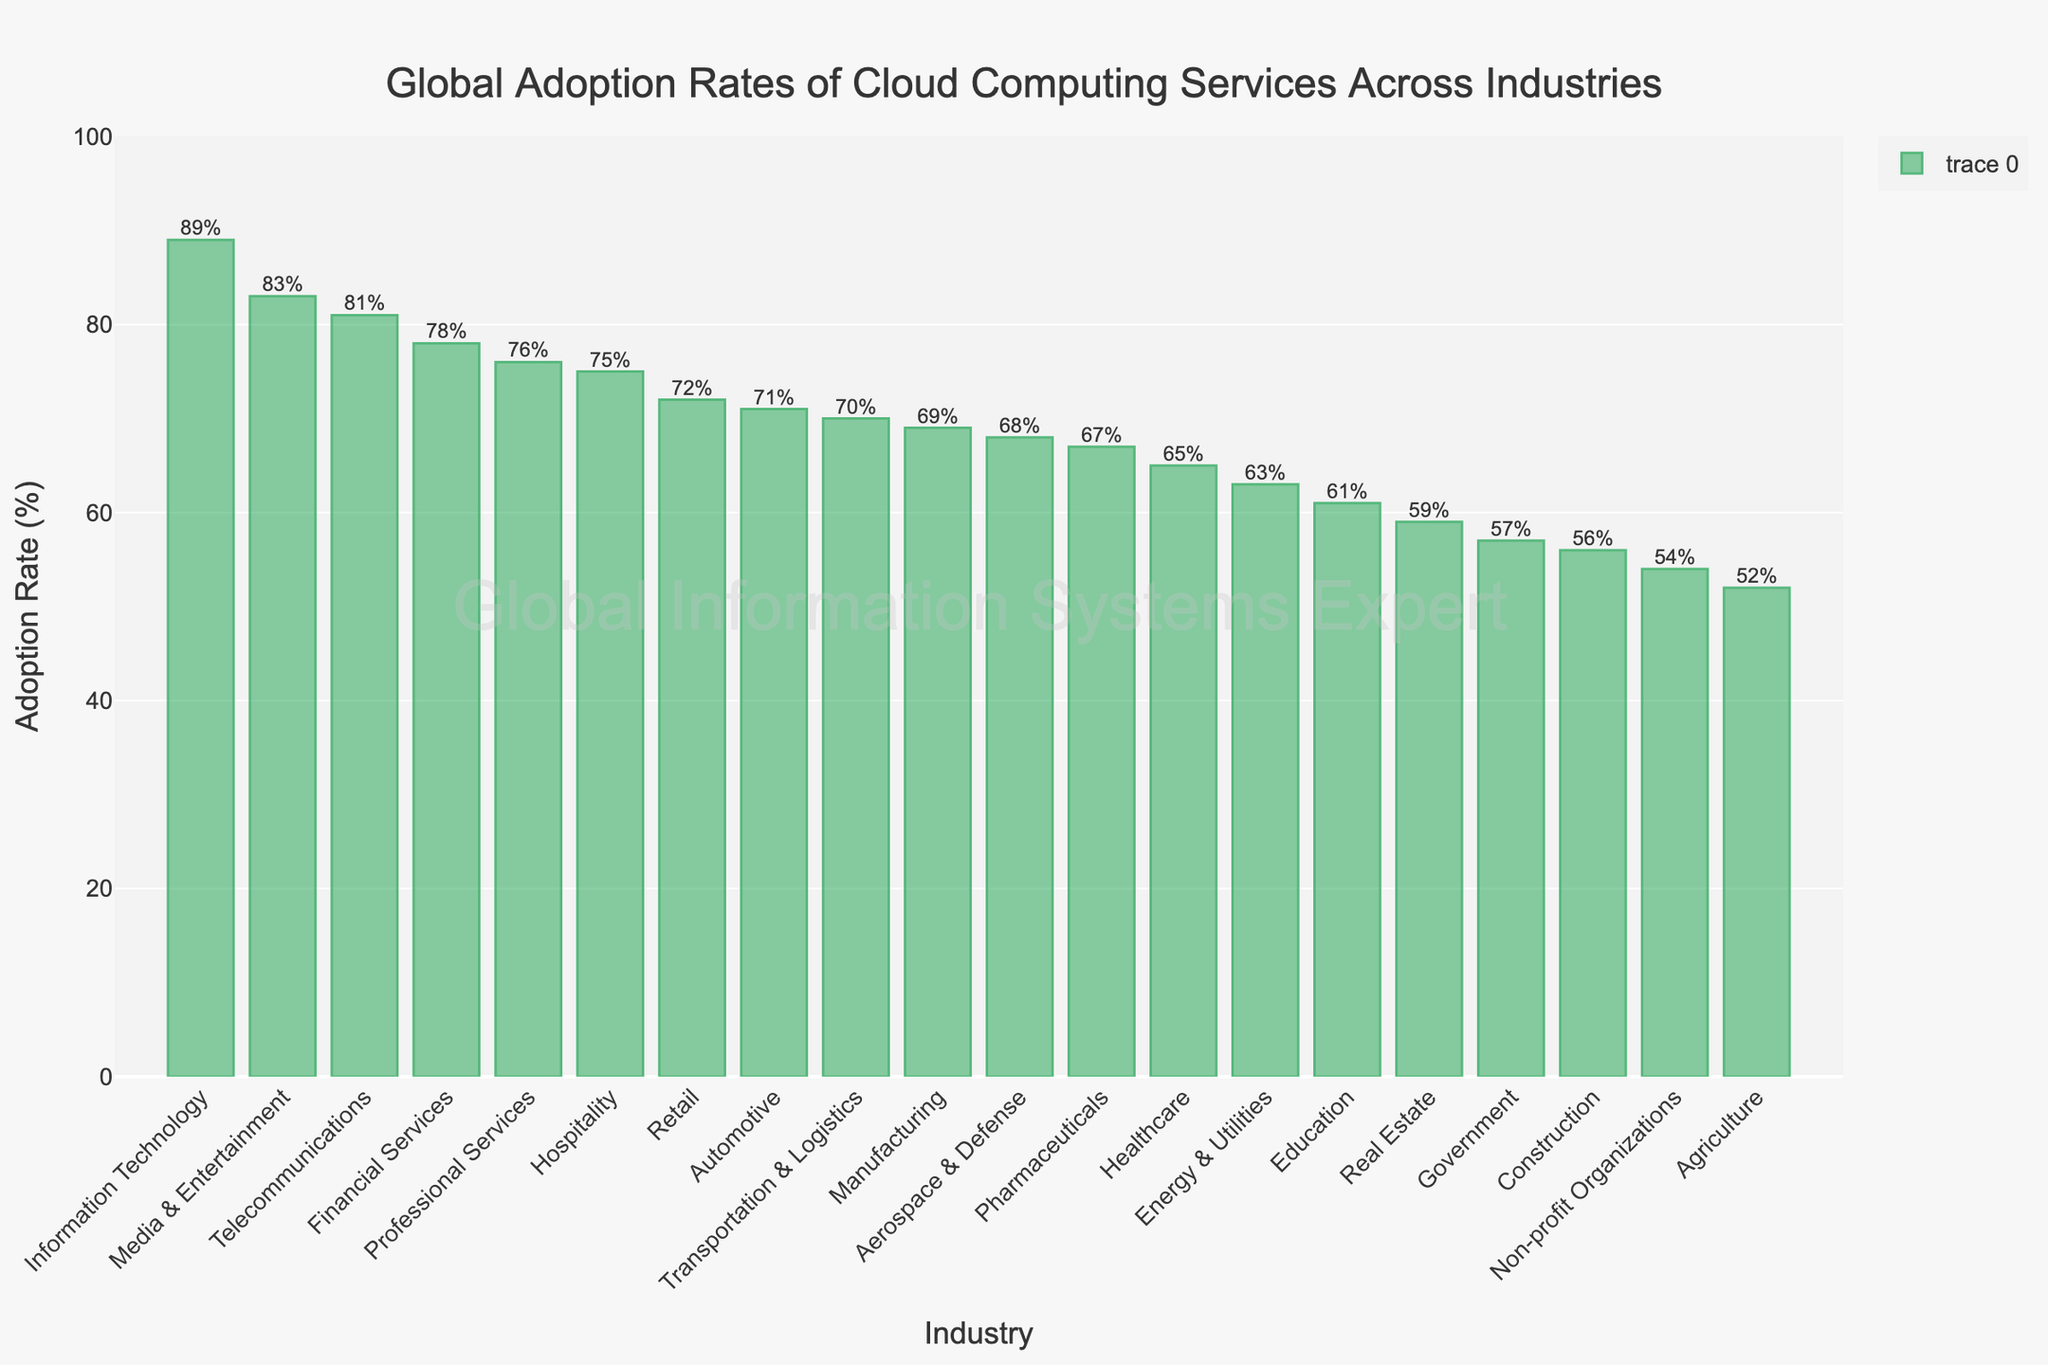Which industry has the highest cloud computing adoption rate? To find the highest adoption rate, locate the tallest bar in the chart. The industry with the highest bar is Information Technology.
Answer: Information Technology Which industry has the lowest cloud computing adoption rate? To find the lowest adoption rate, identify the shortest bar in the chart. The industry with the shortest bar is Agriculture.
Answer: Agriculture What is the average adoption rate of the Financial Services and Healthcare industries? Add the adoption rates of both industries and then divide by 2. Financial Services has 78% and Healthcare has 65%. Calculation: (78 + 65) / 2 = 71.5
Answer: 71.5% How much higher is the cloud adoption rate in Media & Entertainment compared to Real Estate? Identify the adoption rates for both industries and subtract the smaller rate from the larger. Media & Entertainment is 83%, Real Estate is 59%. Calculation: 83 - 59 = 24
Answer: 24% What is the difference in cloud adoption rates between Telecommunications and Government? Identify the adoption rates for both industries and subtract the smaller rate from the larger. Telecommunications is 81%, Government is 57%. Calculation: 81 - 57 = 24
Answer: 24% Which industries have an adoption rate higher than 70% but less than 80%? Check all bars whose height falls between these percentages. The industries are Financial Services, Retail, Hospitality, and Professional Services.
Answer: Financial Services, Retail, Hospitality, Professional Services What is the combined adoption rate of the Education and Agriculture industries? Add the adoption rates of both industries. Education is 61%, Agriculture is 52%. Calculation: 61 + 52 = 113
Answer: 113% How does the adoption rate of Energy & Utilities compare to Automotive? Find the adoption rates of both industries and compare them. Energy & Utilities is 63%, Automotive is 71%. Automotive has a higher adoption rate.
Answer: Automotive has a higher adoption rate What is the median cloud adoption rate of the industries shown? First, list all the adoption rates in ascending order: 52, 54, 56, 57, 59, 61, 63, 65, 67, 68, 69, 70, 71, 72, 75, 76, 78, 81, 83, 89. With 20 values, the median will be the average of the 10th and 11th values, which are 68 and 69. Calculation: (68 + 69) / 2 = 68.5
Answer: 68.5 How many industries have an adoption rate below 60%? Count all bars with heights less than 60%. The industries are Government, Agriculture, Real Estate, Non-profit Organizations, and Construction. There are 5 such industries.
Answer: 5 